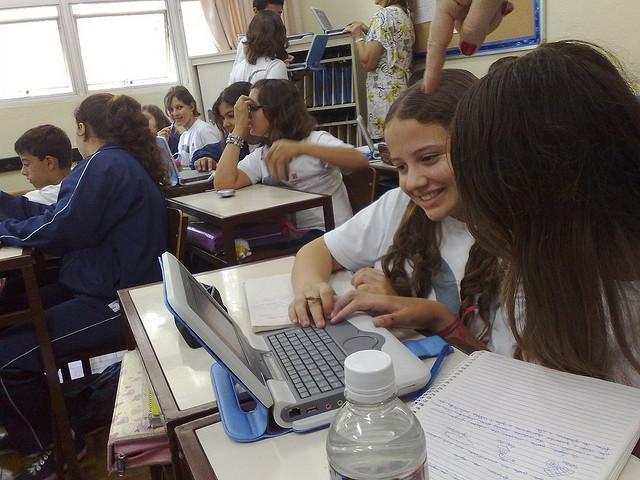Who is probably pointing above the students?
Choose the right answer and clarify with the format: 'Answer: answer
Rationale: rationale.'
Options: Teacher, janitor, student, parent. Answer: teacher.
Rationale: The students look to be sitting at a desk in a classroom, and the pointed finger seems to belong to an older person. the only older person typically in a classroom would be the teacher. 